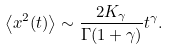Convert formula to latex. <formula><loc_0><loc_0><loc_500><loc_500>\left < x ^ { 2 } ( t ) \right > \sim \frac { 2 K _ { \gamma } } { \Gamma ( 1 + \gamma ) } t ^ { \gamma } .</formula> 